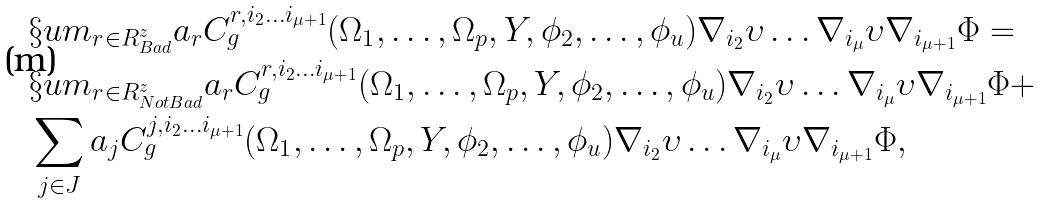Convert formula to latex. <formula><loc_0><loc_0><loc_500><loc_500>& \S u m _ { r \in R ^ { z } _ { B a d } } a _ { r } C ^ { r , i _ { 2 } \dots i _ { \mu + 1 } } _ { g } ( \Omega _ { 1 } , \dots , \Omega _ { p } , Y , \phi _ { 2 } , \dots , \phi _ { u } ) \nabla _ { i _ { 2 } } \upsilon \dots \nabla _ { i _ { \mu } } \upsilon \nabla _ { i _ { \mu + 1 } } \Phi = \\ & \S u m _ { r \in R ^ { z } _ { N o t B a d } } a _ { r } C ^ { r , i _ { 2 } \dots i _ { \mu + 1 } } _ { g } ( \Omega _ { 1 } , \dots , \Omega _ { p } , Y , \phi _ { 2 } , \dots , \phi _ { u } ) \nabla _ { i _ { 2 } } \upsilon \dots \nabla _ { i _ { \mu } } \upsilon \nabla _ { i _ { \mu + 1 } } \Phi + \\ & \sum _ { j \in J } a _ { j } C ^ { j , i _ { 2 } \dots i _ { \mu + 1 } } _ { g } ( \Omega _ { 1 } , \dots , \Omega _ { p } , Y , \phi _ { 2 } , \dots , \phi _ { u } ) \nabla _ { i _ { 2 } } \upsilon \dots \nabla _ { i _ { \mu } } \upsilon \nabla _ { i _ { \mu + 1 } } \Phi ,</formula> 